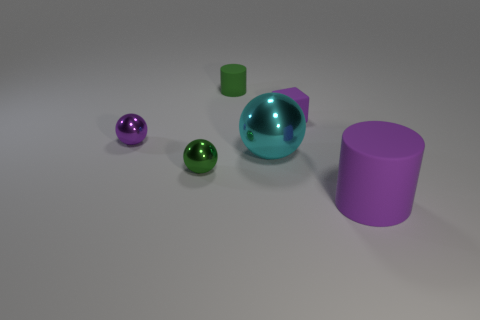Is the number of large cyan metallic things in front of the cyan shiny thing less than the number of cylinders that are behind the purple block?
Keep it short and to the point. Yes. There is a purple rubber block; is its size the same as the cylinder to the left of the purple cylinder?
Provide a short and direct response. Yes. The rubber thing that is both behind the purple rubber cylinder and in front of the small green cylinder has what shape?
Your response must be concise. Cube. What size is the cyan thing that is the same material as the small purple ball?
Provide a succinct answer. Large. There is a ball that is to the left of the green metal thing; what number of big objects are to the right of it?
Provide a succinct answer. 2. Is the small green object that is in front of the rubber block made of the same material as the big purple object?
Ensure brevity in your answer.  No. What is the size of the purple rubber thing behind the tiny shiny object that is behind the small green metal ball?
Make the answer very short. Small. How big is the purple matte object behind the rubber cylinder in front of the cylinder behind the big matte cylinder?
Offer a terse response. Small. There is a big object behind the large cylinder; is its shape the same as the purple rubber thing behind the purple cylinder?
Provide a succinct answer. No. How many other things are there of the same color as the block?
Offer a very short reply. 2. 